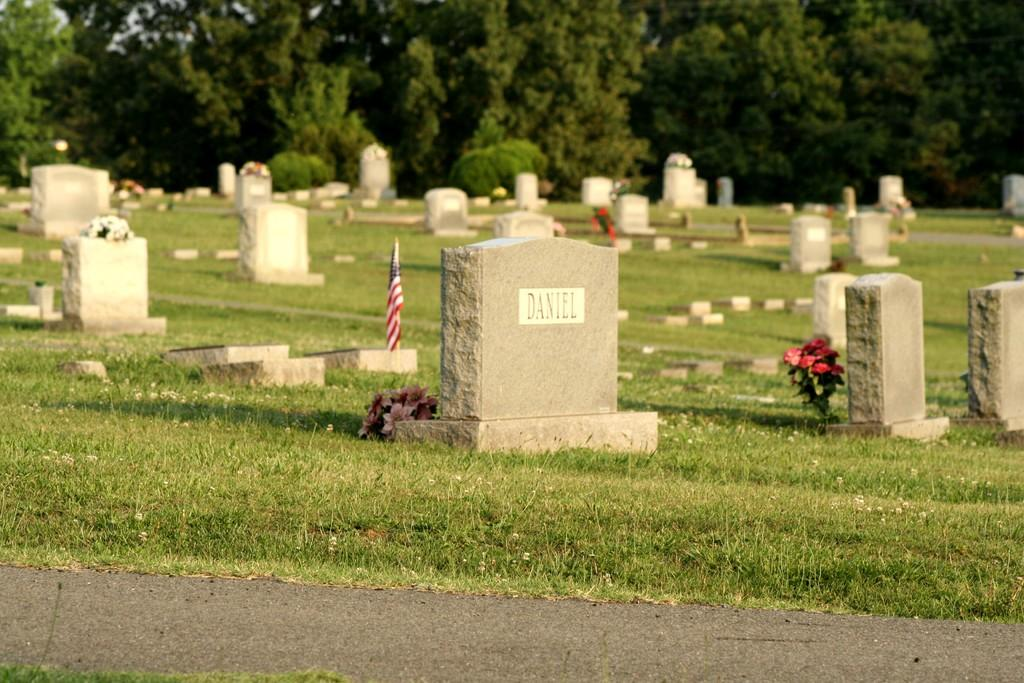What type of location is depicted in the image? There is a graveyard in the image. What is the terrain like in the image? There is grassy land in the image. What type of vegetation is present in the image? There are many trees in the image. What type of lettuce is growing in the graveyard in the image? There is no lettuce present in the image; it is a graveyard with grassy land and trees. 